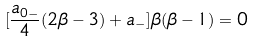Convert formula to latex. <formula><loc_0><loc_0><loc_500><loc_500>[ \frac { a _ { 0 - } } { 4 } ( 2 \beta - 3 ) + a _ { - } ] \beta ( \beta - 1 ) = 0</formula> 